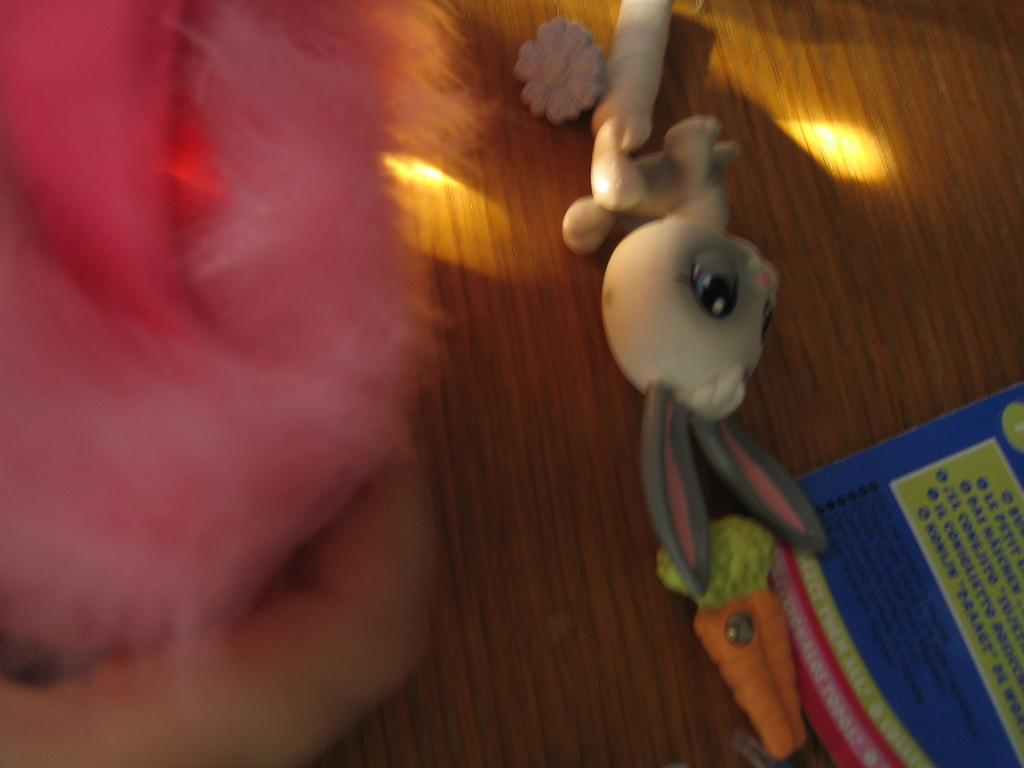What objects are present in the image? There are toys in the image. What type of surface are the toys placed on? The toys are on a wooden surface. What type of furniture can be seen in the image? There is no furniture visible in the image; only toys on a wooden surface are present. What type of protest is taking place in the image? There is no protest depicted in the image; it features toys on a wooden surface. 